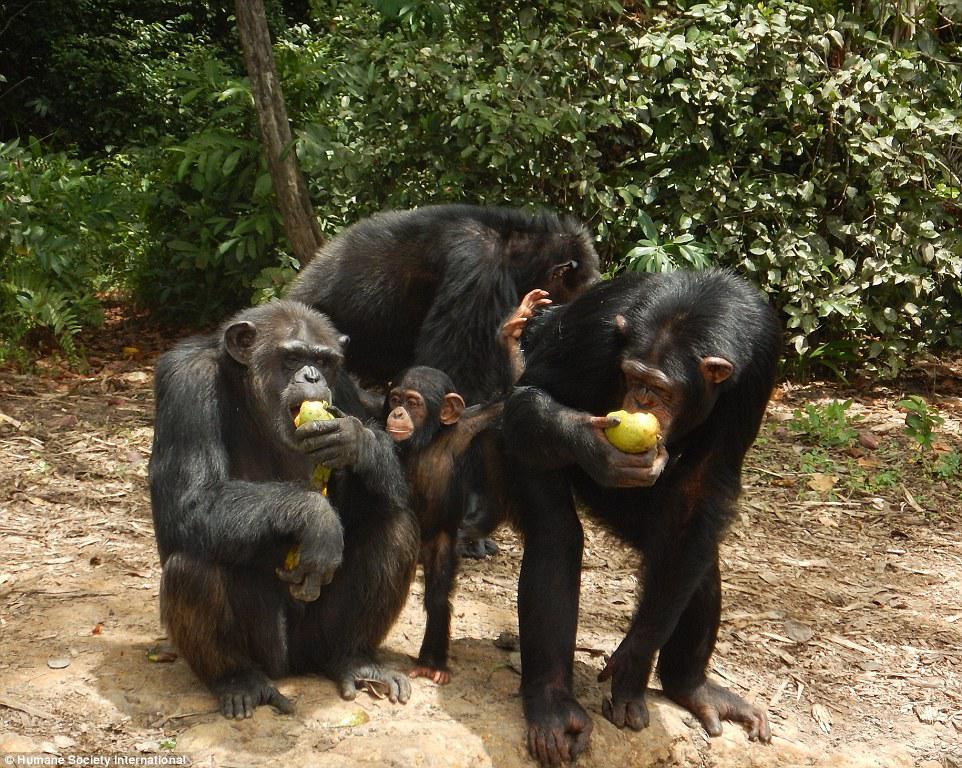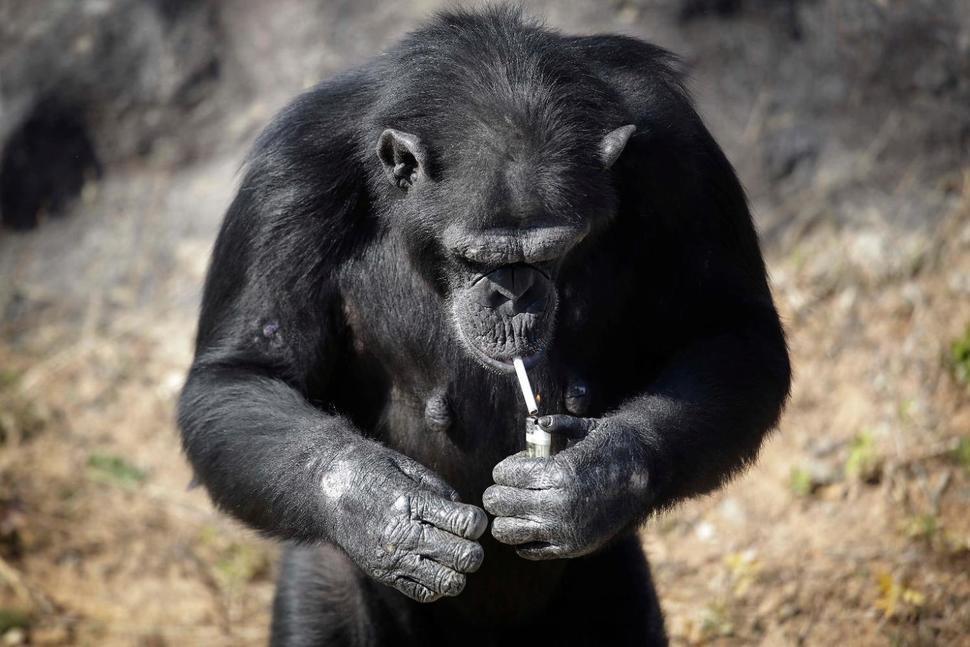The first image is the image on the left, the second image is the image on the right. For the images shown, is this caption "A baboon is carrying a baby baboon in the image on the right." true? Answer yes or no. No. The first image is the image on the left, the second image is the image on the right. Assess this claim about the two images: "An image contains exactly two chimps, and both chimps are sitting on the ground.". Correct or not? Answer yes or no. No. 